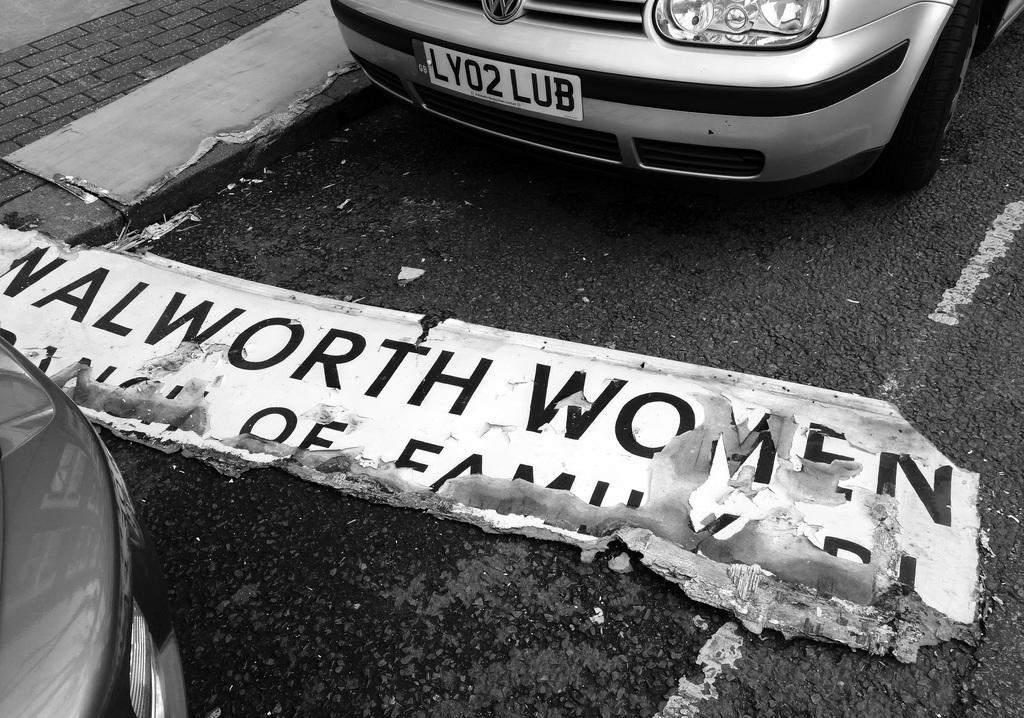Could you give a brief overview of what you see in this image? In this image we can see some vehicles on the road and there is a board with some text and to the side there is a pavement. 